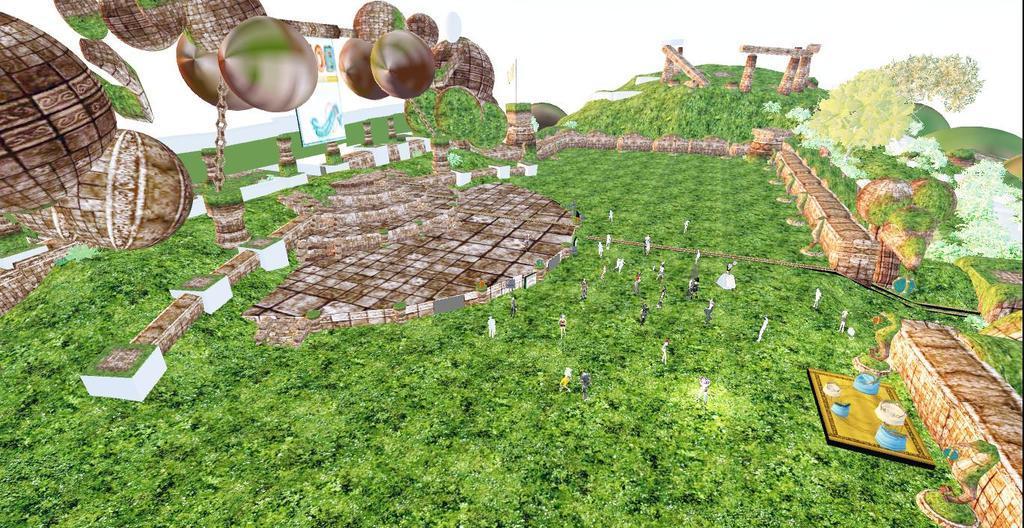Could you give a brief overview of what you see in this image? This is a graphical picture and in this picture we can see a poster, plants, animals, pillars and some objects and in the background we can see white color. 